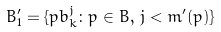Convert formula to latex. <formula><loc_0><loc_0><loc_500><loc_500>B ^ { \prime } _ { 1 } = \{ p b _ { k } ^ { j } \colon p \in B , \, j < m ^ { \prime } ( p ) \}</formula> 